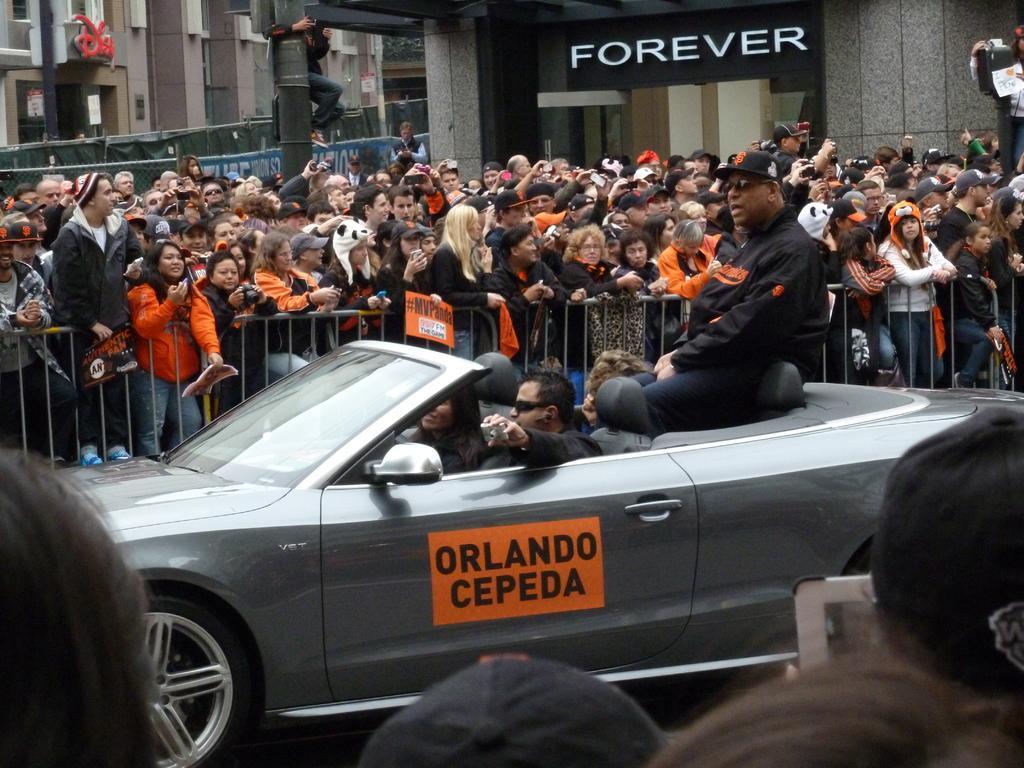In one or two sentences, can you explain what this image depicts? This picture shows few people seated in the car and we see few people standing on the both sides and few are holding cameras in their hands and we see buildings and we see a man standing holding a pole. 